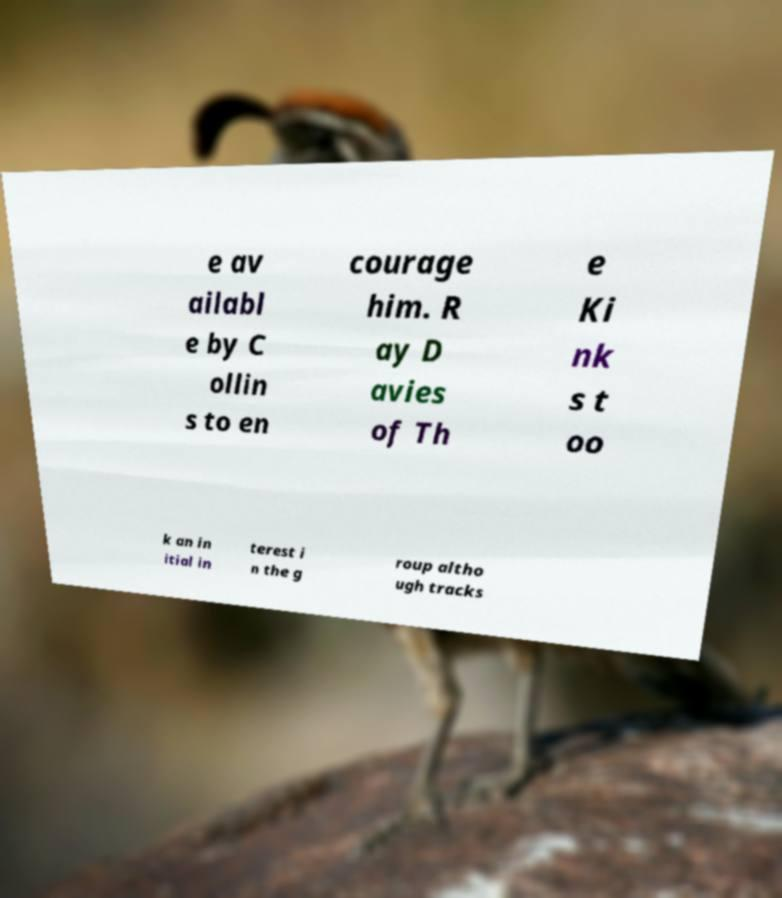Can you read and provide the text displayed in the image?This photo seems to have some interesting text. Can you extract and type it out for me? e av ailabl e by C ollin s to en courage him. R ay D avies of Th e Ki nk s t oo k an in itial in terest i n the g roup altho ugh tracks 